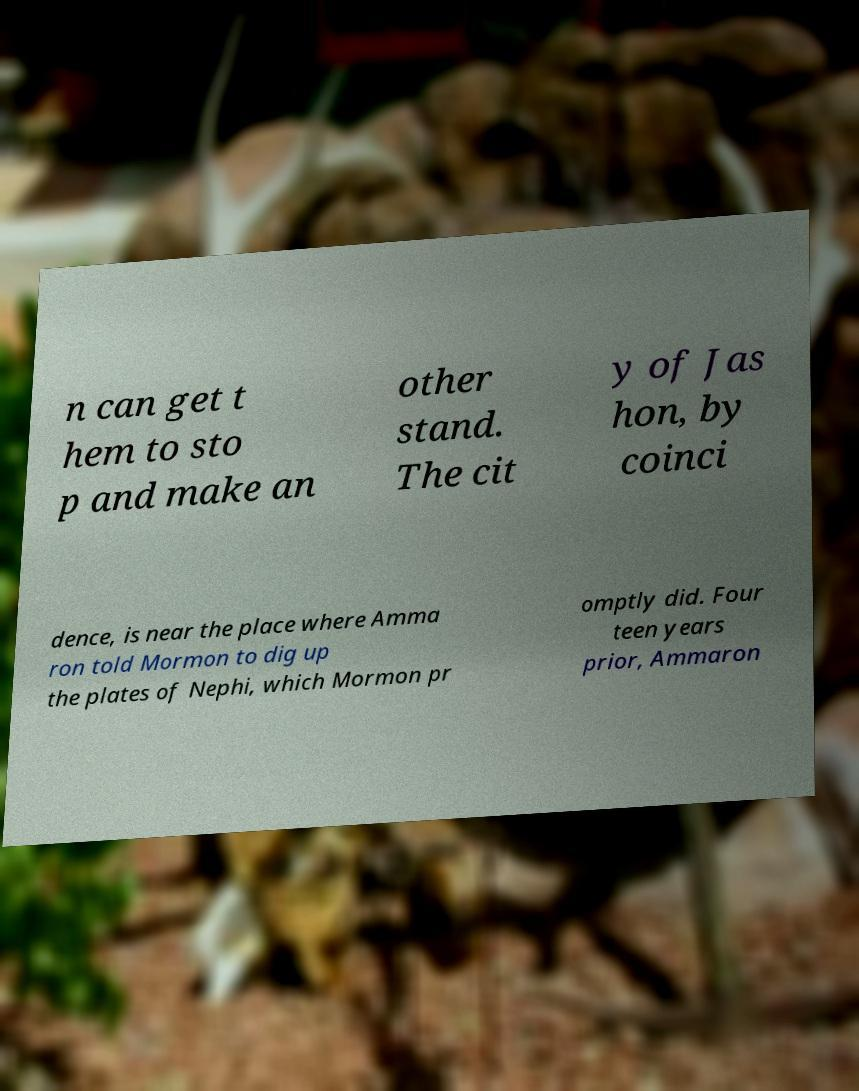There's text embedded in this image that I need extracted. Can you transcribe it verbatim? n can get t hem to sto p and make an other stand. The cit y of Jas hon, by coinci dence, is near the place where Amma ron told Mormon to dig up the plates of Nephi, which Mormon pr omptly did. Four teen years prior, Ammaron 